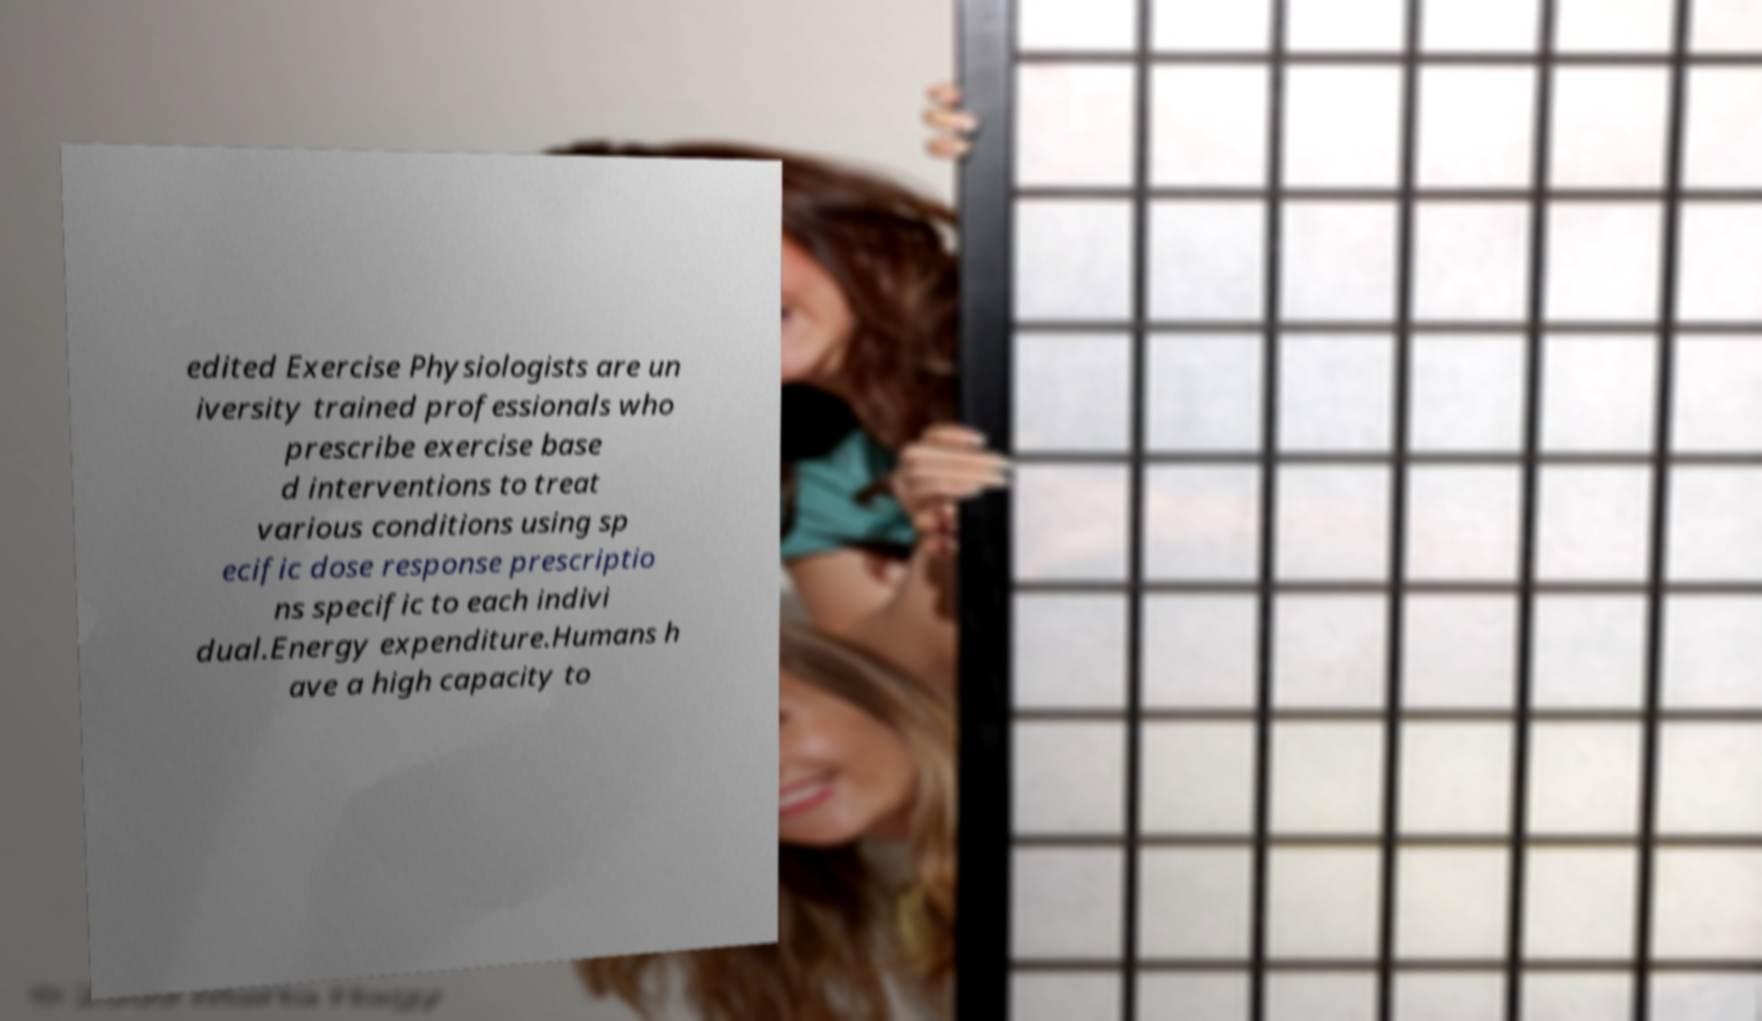What messages or text are displayed in this image? I need them in a readable, typed format. edited Exercise Physiologists are un iversity trained professionals who prescribe exercise base d interventions to treat various conditions using sp ecific dose response prescriptio ns specific to each indivi dual.Energy expenditure.Humans h ave a high capacity to 